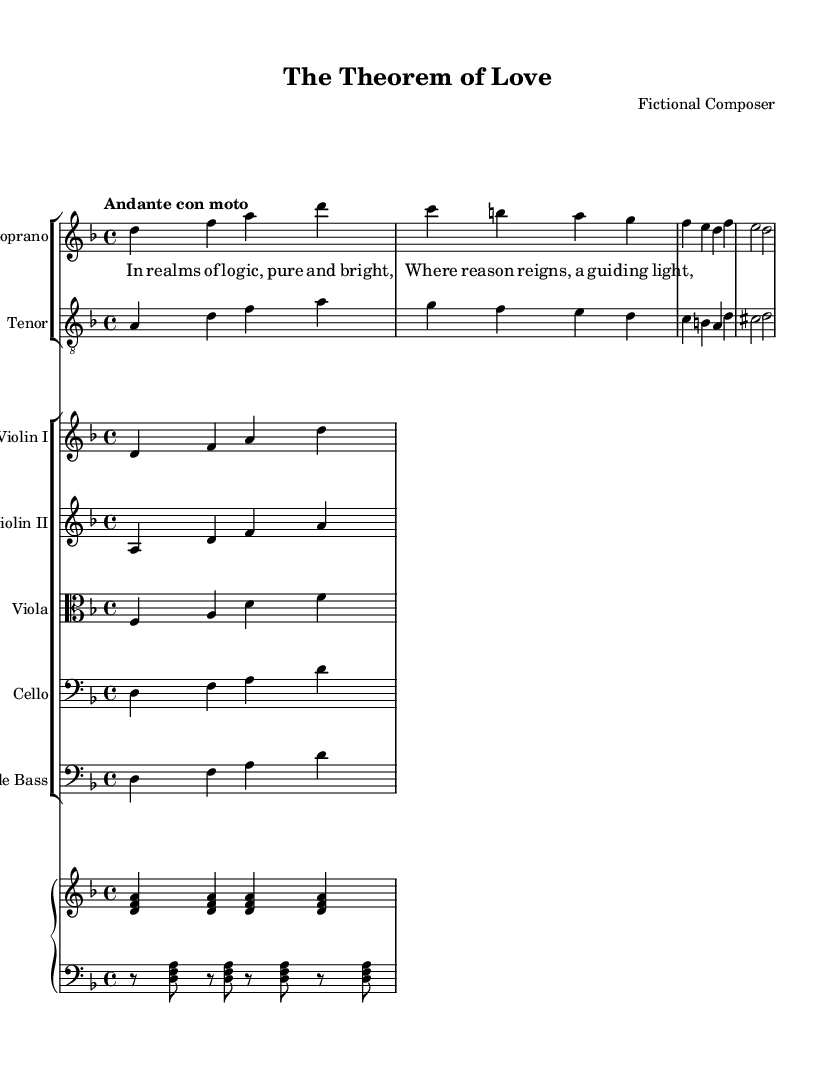What is the key signature of this music? The key signature is indicated at the beginning of the staff and shows 1 flat, which corresponds to D minor.
Answer: D minor What is the time signature of this music? The time signature appears near the beginning of the score, displayed as a fraction with a '4' on top and another '4' on the bottom, indicating four beats per measure.
Answer: 4/4 What is the tempo marking for this piece? The tempo marking is found at the beginning of the score, written in Italian, informing the performance speed. Here, it is "Andante con moto," suggesting a moderate pace.
Answer: Andante con moto Which instruments are featured in the score? By reviewing the staff groups, we can identify the instruments listed as Soprano, Tenor, Violin I, Violin II, Viola, Cello, Double Bass, and Piano.
Answer: Soprano, Tenor, Violin I, Violin II, Viola, Cello, Double Bass, Piano What is the lyrical theme suggested in the verse? The lyrics focus on themes related to logic and reasoning, as indicated by words like "logic," "reason," and "guiding light," which encompass an intellectual concept.
Answer: Logic, reasoning How many parts are there in the vocal score? The vocal score contains two parts: Soprano and Tenor, which are clearly delineated in separate staves.
Answer: 2 Which musical expression is implied by the indicated dynamics in the score? While the provided excerpt does not include explicit dynamics, the phrasing of the lyrical text and the slow tempo often suggest a tender and reflective expression characteristic of Romantic music.
Answer: Reflective 